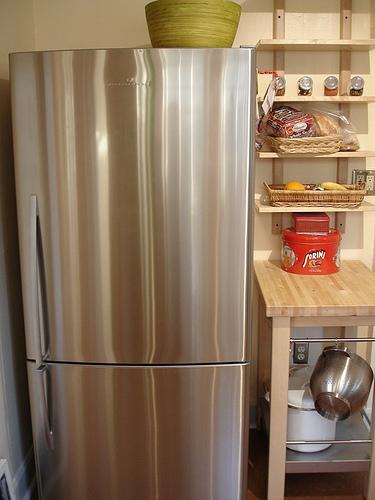What does the surface of the refrigerator feel like?
Write a very short answer. Smooth. Is the refrigerator door open?
Be succinct. No. Where is the outlet?
Be succinct. Under table. Where is the soda?
Be succinct. Refrigerator. What is placed on top of the refrigerator?
Short answer required. Bowl. 